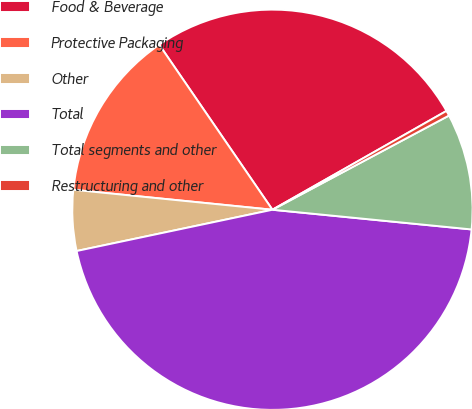Convert chart. <chart><loc_0><loc_0><loc_500><loc_500><pie_chart><fcel>Food & Beverage<fcel>Protective Packaging<fcel>Other<fcel>Total<fcel>Total segments and other<fcel>Restructuring and other<nl><fcel>26.35%<fcel>13.84%<fcel>4.9%<fcel>45.13%<fcel>9.37%<fcel>0.42%<nl></chart> 